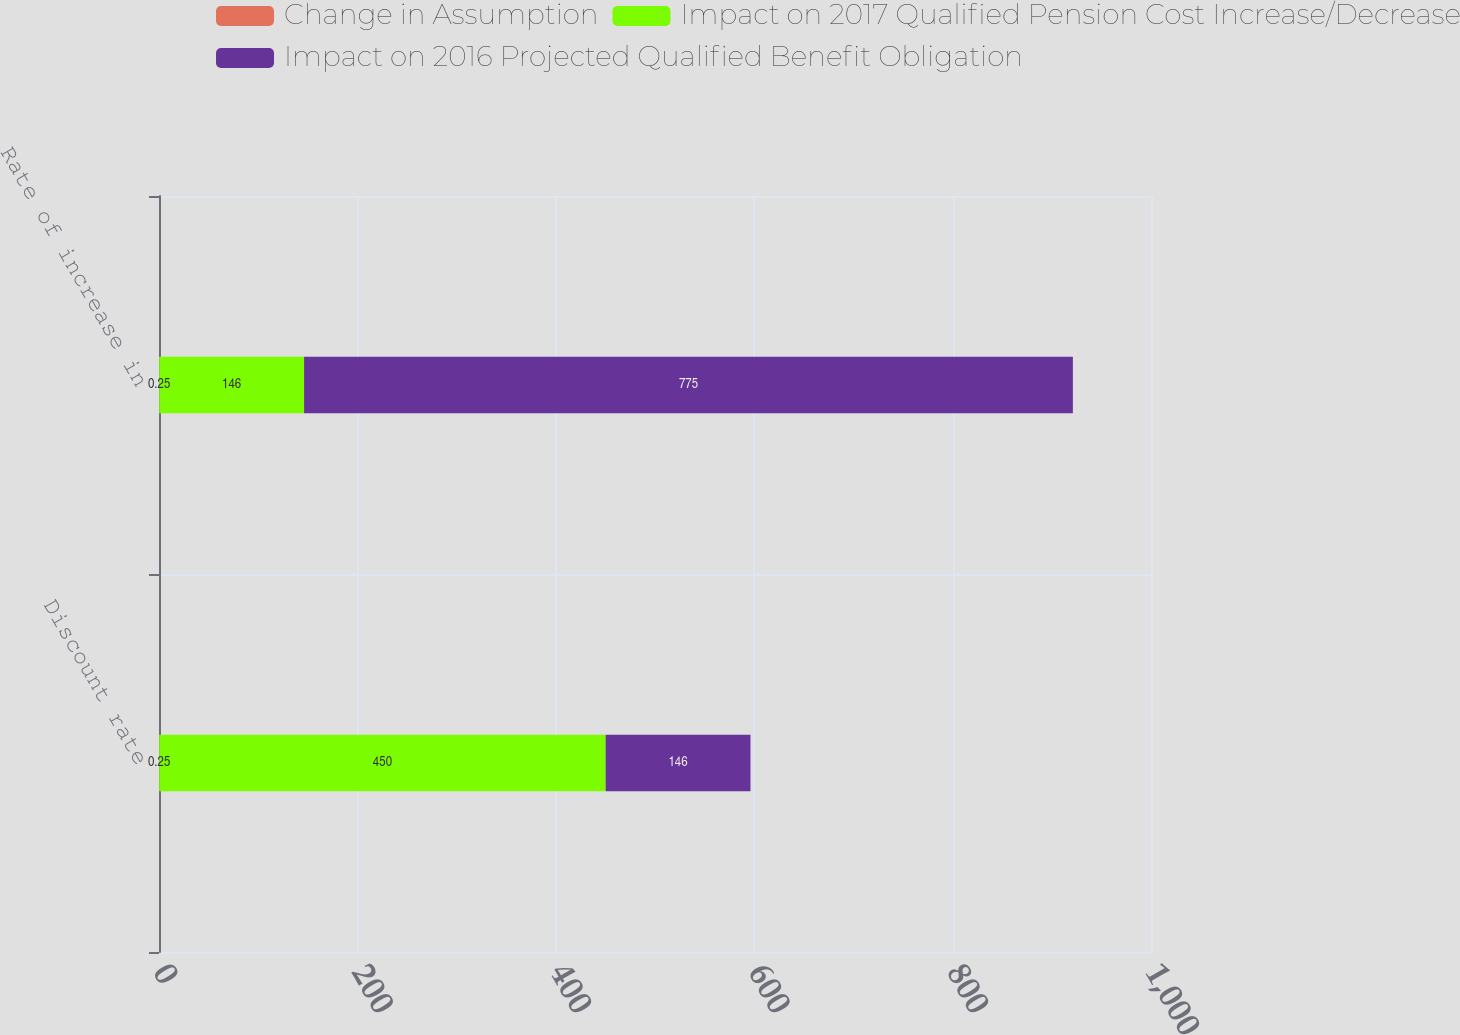Convert chart. <chart><loc_0><loc_0><loc_500><loc_500><stacked_bar_chart><ecel><fcel>Discount rate<fcel>Rate of increase in<nl><fcel>Change in Assumption<fcel>0.25<fcel>0.25<nl><fcel>Impact on 2017 Qualified Pension Cost Increase/Decrease<fcel>450<fcel>146<nl><fcel>Impact on 2016 Projected Qualified Benefit Obligation<fcel>146<fcel>775<nl></chart> 